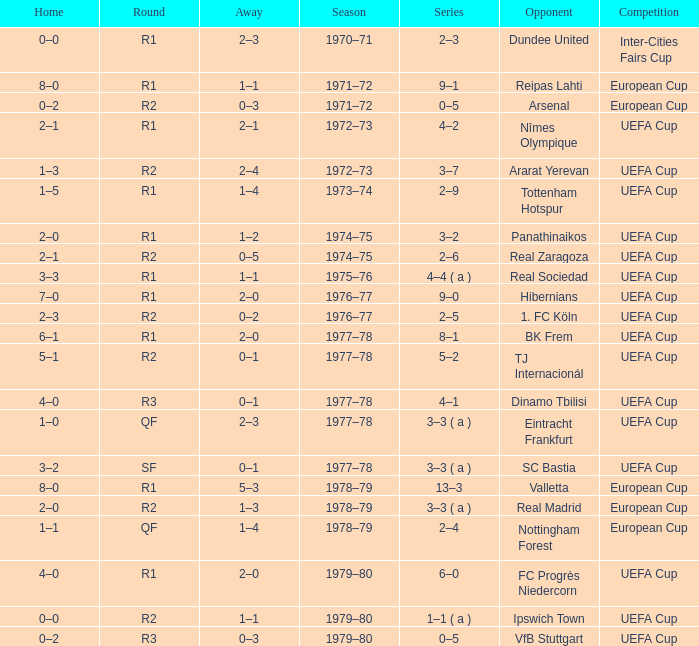Could you help me parse every detail presented in this table? {'header': ['Home', 'Round', 'Away', 'Season', 'Series', 'Opponent', 'Competition'], 'rows': [['0–0', 'R1', '2–3', '1970–71', '2–3', 'Dundee United', 'Inter-Cities Fairs Cup'], ['8–0', 'R1', '1–1', '1971–72', '9–1', 'Reipas Lahti', 'European Cup'], ['0–2', 'R2', '0–3', '1971–72', '0–5', 'Arsenal', 'European Cup'], ['2–1', 'R1', '2–1', '1972–73', '4–2', 'Nîmes Olympique', 'UEFA Cup'], ['1–3', 'R2', '2–4', '1972–73', '3–7', 'Ararat Yerevan', 'UEFA Cup'], ['1–5', 'R1', '1–4', '1973–74', '2–9', 'Tottenham Hotspur', 'UEFA Cup'], ['2–0', 'R1', '1–2', '1974–75', '3–2', 'Panathinaikos', 'UEFA Cup'], ['2–1', 'R2', '0–5', '1974–75', '2–6', 'Real Zaragoza', 'UEFA Cup'], ['3–3', 'R1', '1–1', '1975–76', '4–4 ( a )', 'Real Sociedad', 'UEFA Cup'], ['7–0', 'R1', '2–0', '1976–77', '9–0', 'Hibernians', 'UEFA Cup'], ['2–3', 'R2', '0–2', '1976–77', '2–5', '1. FC Köln', 'UEFA Cup'], ['6–1', 'R1', '2–0', '1977–78', '8–1', 'BK Frem', 'UEFA Cup'], ['5–1', 'R2', '0–1', '1977–78', '5–2', 'TJ Internacionál', 'UEFA Cup'], ['4–0', 'R3', '0–1', '1977–78', '4–1', 'Dinamo Tbilisi', 'UEFA Cup'], ['1–0', 'QF', '2–3', '1977–78', '3–3 ( a )', 'Eintracht Frankfurt', 'UEFA Cup'], ['3–2', 'SF', '0–1', '1977–78', '3–3 ( a )', 'SC Bastia', 'UEFA Cup'], ['8–0', 'R1', '5–3', '1978–79', '13–3', 'Valletta', 'European Cup'], ['2–0', 'R2', '1–3', '1978–79', '3–3 ( a )', 'Real Madrid', 'European Cup'], ['1–1', 'QF', '1–4', '1978–79', '2–4', 'Nottingham Forest', 'European Cup'], ['4–0', 'R1', '2–0', '1979–80', '6–0', 'FC Progrès Niedercorn', 'UEFA Cup'], ['0–0', 'R2', '1–1', '1979–80', '1–1 ( a )', 'Ipswich Town', 'UEFA Cup'], ['0–2', 'R3', '0–3', '1979–80', '0–5', 'VfB Stuttgart', 'UEFA Cup']]} Which Season has an Opponent of hibernians? 1976–77. 